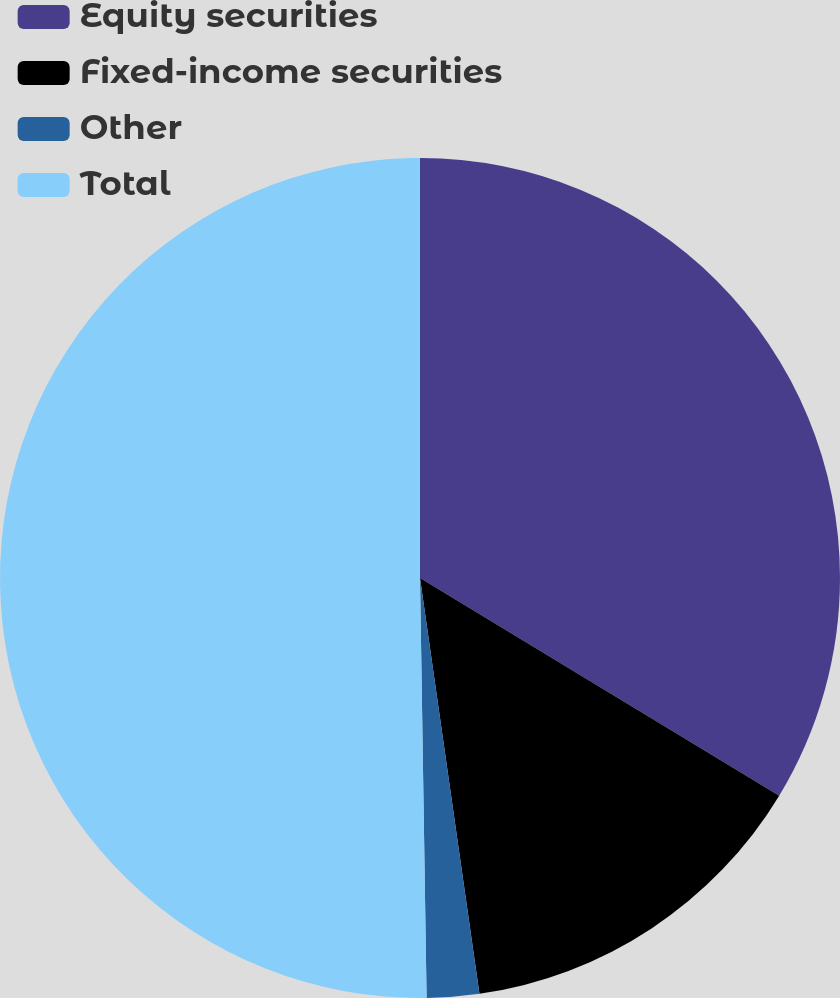Convert chart to OTSL. <chart><loc_0><loc_0><loc_500><loc_500><pie_chart><fcel>Equity securities<fcel>Fixed-income securities<fcel>Other<fcel>Total<nl><fcel>33.67%<fcel>14.07%<fcel>2.01%<fcel>50.25%<nl></chart> 